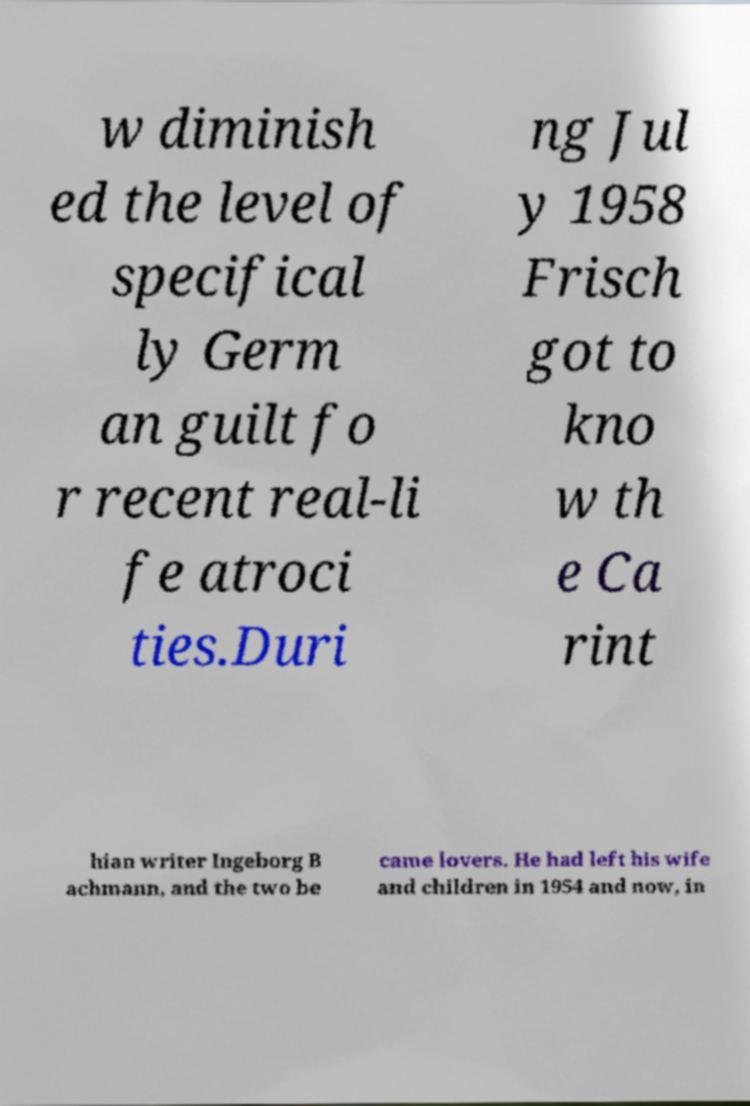There's text embedded in this image that I need extracted. Can you transcribe it verbatim? w diminish ed the level of specifical ly Germ an guilt fo r recent real-li fe atroci ties.Duri ng Jul y 1958 Frisch got to kno w th e Ca rint hian writer Ingeborg B achmann, and the two be came lovers. He had left his wife and children in 1954 and now, in 